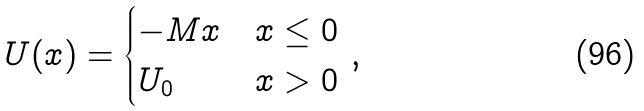<formula> <loc_0><loc_0><loc_500><loc_500>U ( x ) = \begin{cases} - M x & x \leq 0 \\ U _ { 0 } & x > 0 \end{cases} \, ,</formula> 